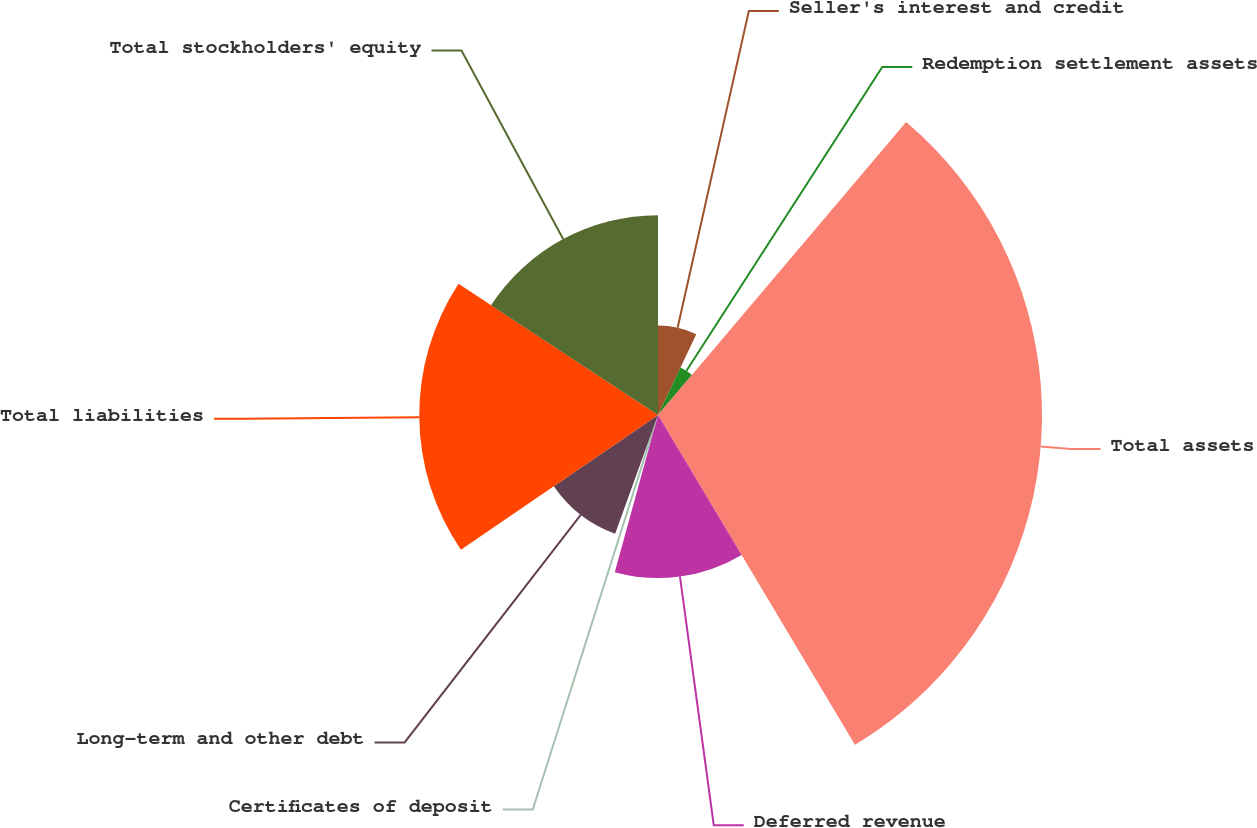Convert chart to OTSL. <chart><loc_0><loc_0><loc_500><loc_500><pie_chart><fcel>Seller's interest and credit<fcel>Redemption settlement assets<fcel>Total assets<fcel>Deferred revenue<fcel>Certificates of deposit<fcel>Long-term and other debt<fcel>Total liabilities<fcel>Total stockholders' equity<nl><fcel>7.04%<fcel>4.14%<fcel>30.24%<fcel>12.84%<fcel>1.24%<fcel>9.94%<fcel>18.8%<fcel>15.74%<nl></chart> 